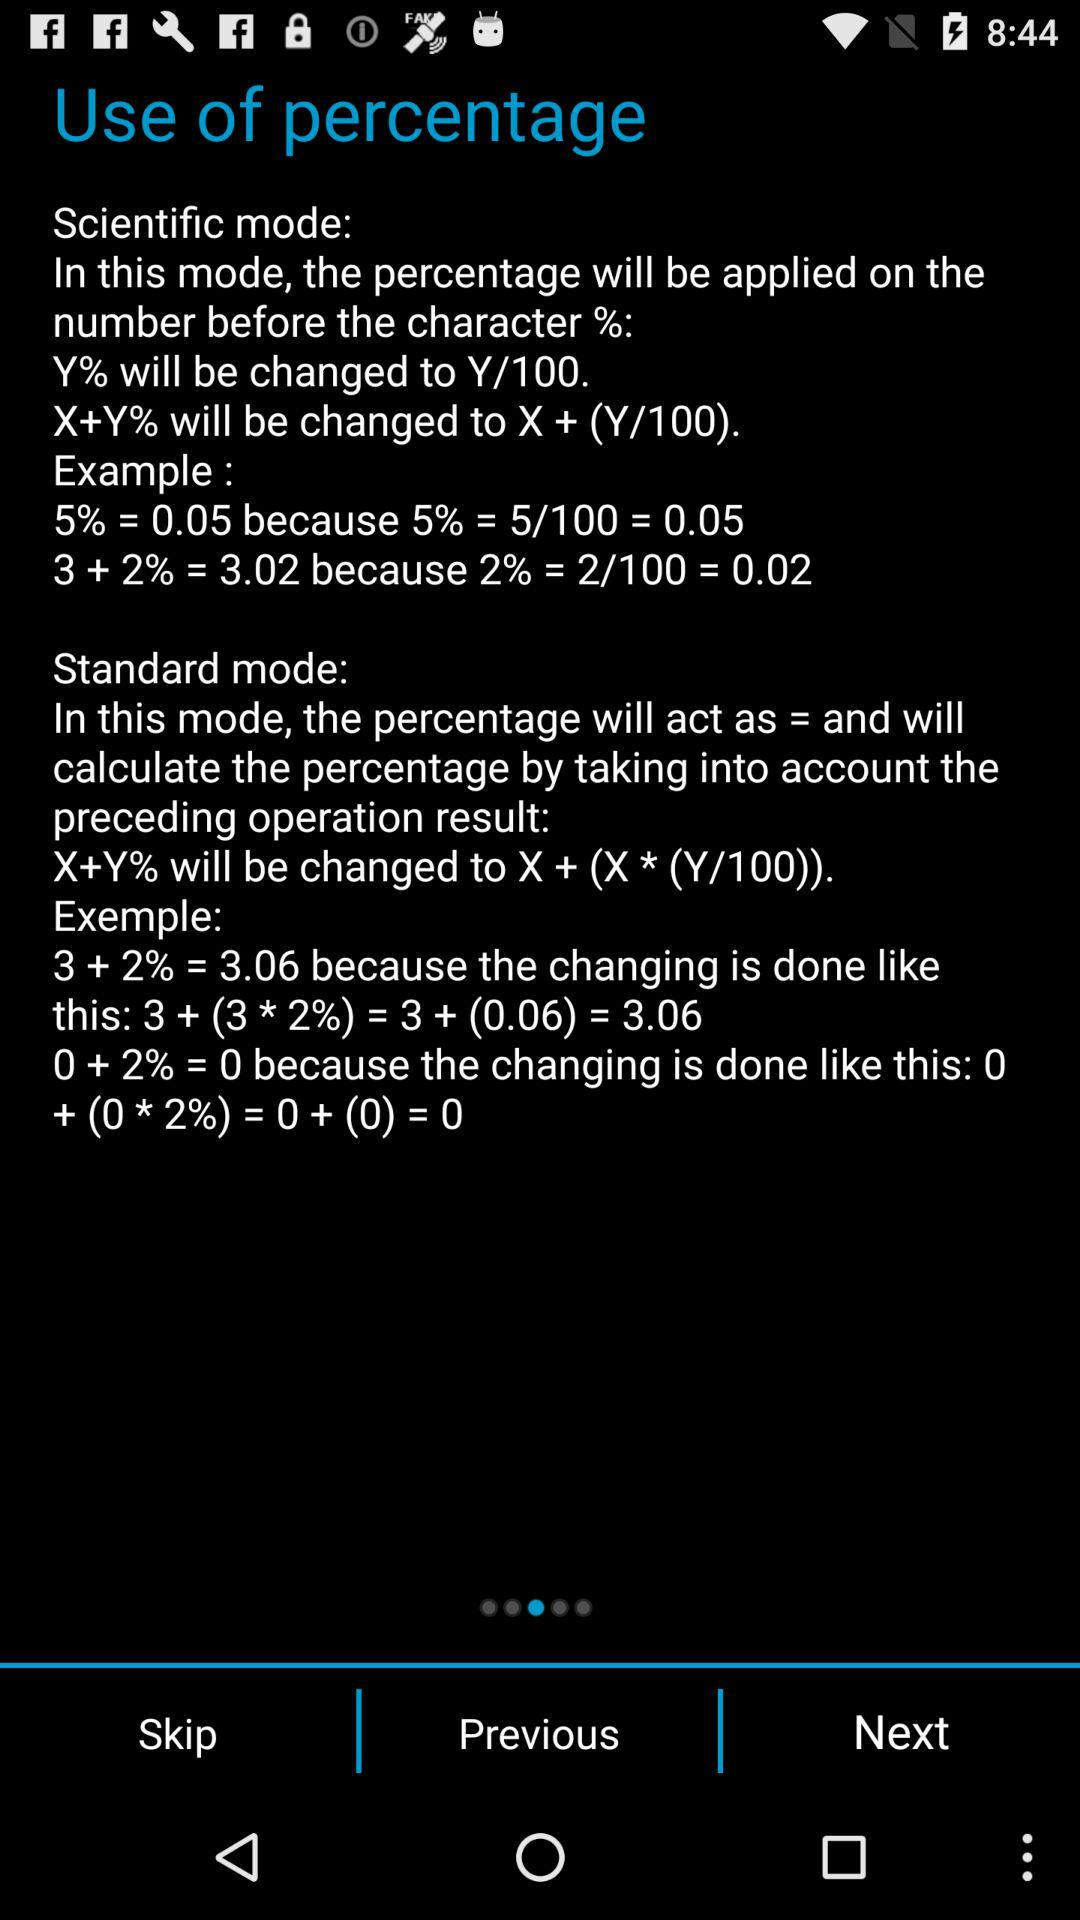What are the different modes of "Use of percentage"? The different modes are "Scientific mode" and "Standard mode". 